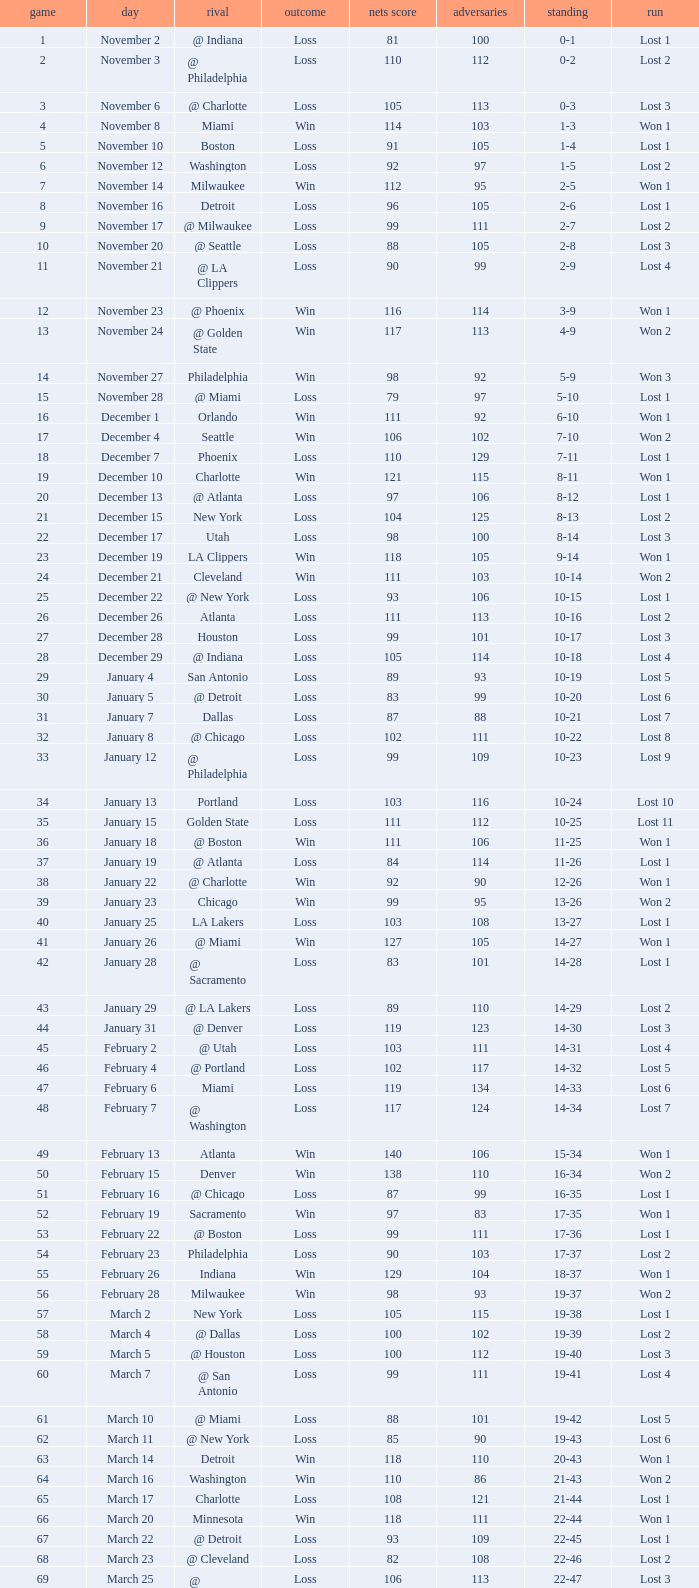What was the average point total for the nets in games before game 9 where the opponents scored less than 95? None. 